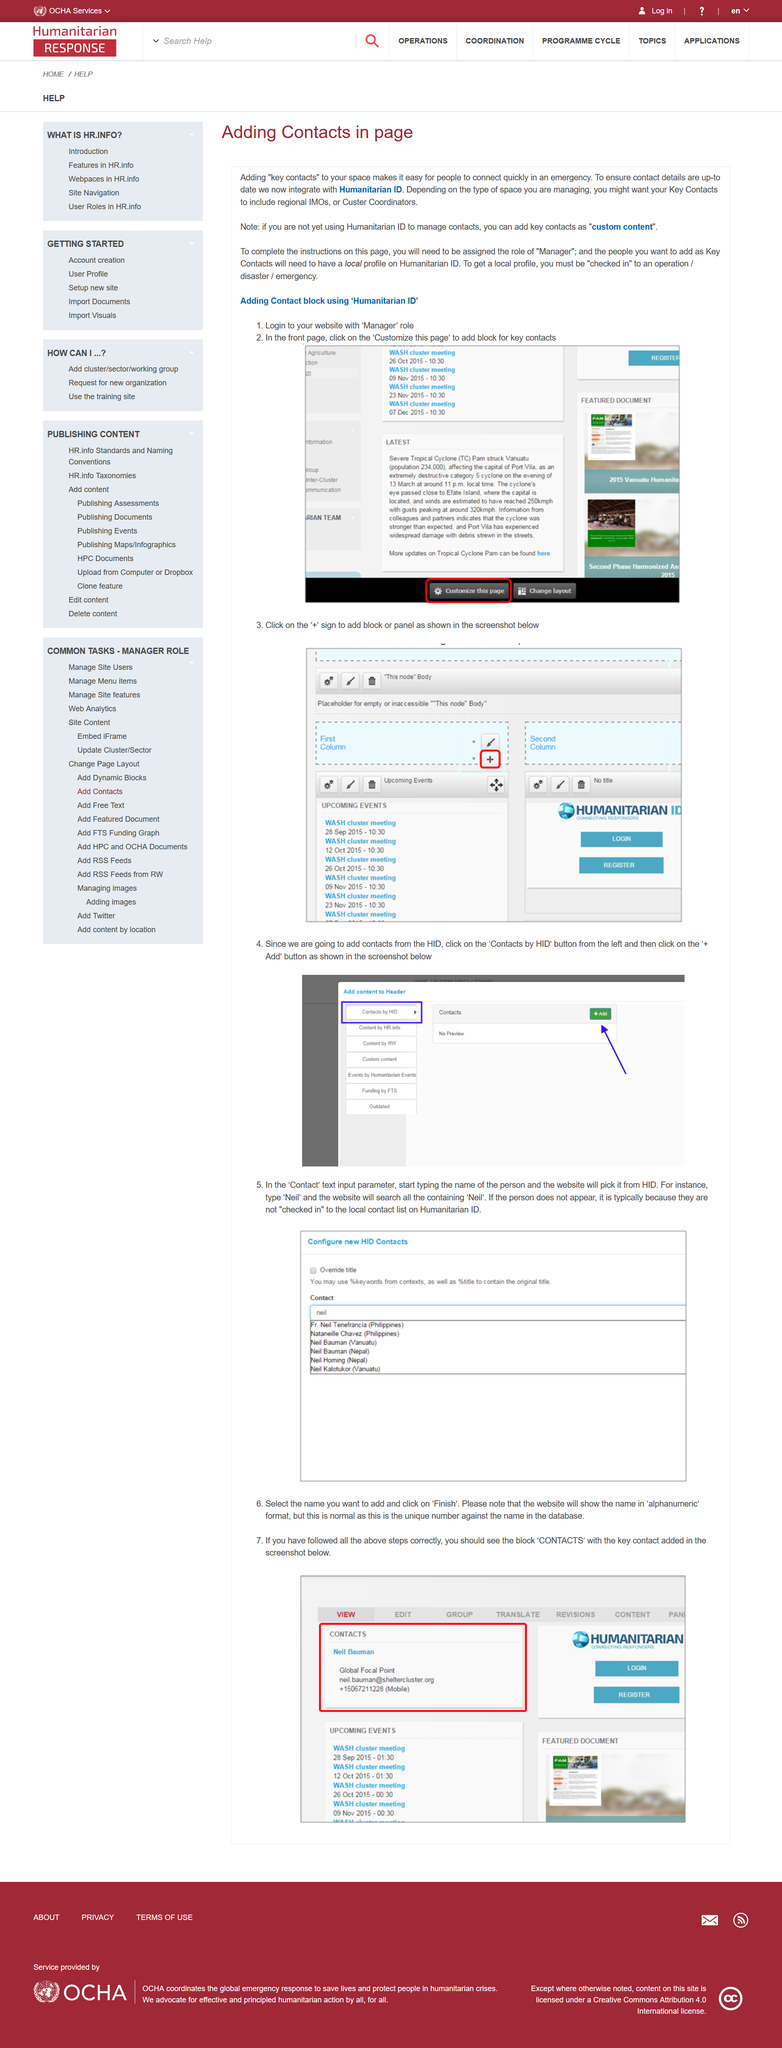Mention a couple of crucial points in this snapshot. Adding a Contact Block with 'Humanitarian ID' requires two steps. To access and complete the instructions on the page, the user must be assigned the role of 'Manager'. Your Key Contacts for the management of various spaces may vary depending on the specific type of space being managed. For instance, if you are responsible for managing a regional IMO or Cluster Coordinator role, then it would be beneficial to include regional IMOs or Cluster Coordinators as your Key Contacts. 